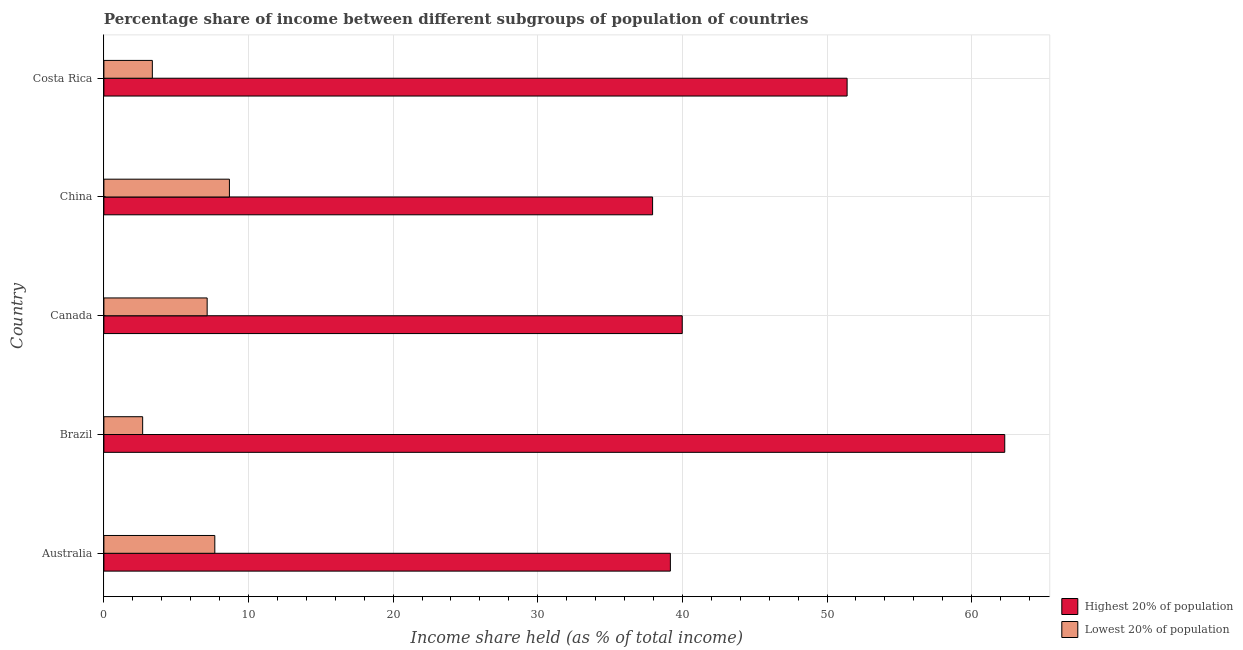How many different coloured bars are there?
Give a very brief answer. 2. How many groups of bars are there?
Your answer should be compact. 5. Are the number of bars on each tick of the Y-axis equal?
Offer a very short reply. Yes. How many bars are there on the 4th tick from the bottom?
Offer a terse response. 2. What is the label of the 2nd group of bars from the top?
Keep it short and to the point. China. What is the income share held by highest 20% of the population in Costa Rica?
Your response must be concise. 51.39. Across all countries, what is the maximum income share held by lowest 20% of the population?
Keep it short and to the point. 8.68. Across all countries, what is the minimum income share held by lowest 20% of the population?
Ensure brevity in your answer.  2.68. In which country was the income share held by highest 20% of the population minimum?
Offer a terse response. China. What is the total income share held by highest 20% of the population in the graph?
Ensure brevity in your answer.  230.78. What is the difference between the income share held by highest 20% of the population in Canada and that in China?
Your answer should be very brief. 2.05. What is the difference between the income share held by lowest 20% of the population in Australia and the income share held by highest 20% of the population in Brazil?
Make the answer very short. -54.62. What is the average income share held by lowest 20% of the population per country?
Provide a succinct answer. 5.9. What is the difference between the income share held by highest 20% of the population and income share held by lowest 20% of the population in Costa Rica?
Your response must be concise. 48.04. What is the ratio of the income share held by highest 20% of the population in Canada to that in China?
Give a very brief answer. 1.05. Is the income share held by lowest 20% of the population in Australia less than that in Costa Rica?
Offer a very short reply. No. Is the difference between the income share held by highest 20% of the population in Canada and China greater than the difference between the income share held by lowest 20% of the population in Canada and China?
Provide a short and direct response. Yes. In how many countries, is the income share held by highest 20% of the population greater than the average income share held by highest 20% of the population taken over all countries?
Make the answer very short. 2. What does the 1st bar from the top in China represents?
Provide a short and direct response. Lowest 20% of population. What does the 1st bar from the bottom in Brazil represents?
Give a very brief answer. Highest 20% of population. How many countries are there in the graph?
Provide a short and direct response. 5. What is the difference between two consecutive major ticks on the X-axis?
Keep it short and to the point. 10. Are the values on the major ticks of X-axis written in scientific E-notation?
Make the answer very short. No. Does the graph contain any zero values?
Ensure brevity in your answer.  No. Where does the legend appear in the graph?
Your answer should be very brief. Bottom right. How many legend labels are there?
Ensure brevity in your answer.  2. What is the title of the graph?
Offer a very short reply. Percentage share of income between different subgroups of population of countries. What is the label or title of the X-axis?
Offer a terse response. Income share held (as % of total income). What is the Income share held (as % of total income) of Highest 20% of population in Australia?
Ensure brevity in your answer.  39.17. What is the Income share held (as % of total income) of Lowest 20% of population in Australia?
Your answer should be very brief. 7.67. What is the Income share held (as % of total income) of Highest 20% of population in Brazil?
Keep it short and to the point. 62.29. What is the Income share held (as % of total income) in Lowest 20% of population in Brazil?
Keep it short and to the point. 2.68. What is the Income share held (as % of total income) of Highest 20% of population in Canada?
Offer a very short reply. 39.99. What is the Income share held (as % of total income) of Lowest 20% of population in Canada?
Provide a succinct answer. 7.14. What is the Income share held (as % of total income) in Highest 20% of population in China?
Your answer should be very brief. 37.94. What is the Income share held (as % of total income) in Lowest 20% of population in China?
Give a very brief answer. 8.68. What is the Income share held (as % of total income) in Highest 20% of population in Costa Rica?
Your response must be concise. 51.39. What is the Income share held (as % of total income) of Lowest 20% of population in Costa Rica?
Ensure brevity in your answer.  3.35. Across all countries, what is the maximum Income share held (as % of total income) of Highest 20% of population?
Your response must be concise. 62.29. Across all countries, what is the maximum Income share held (as % of total income) in Lowest 20% of population?
Your answer should be compact. 8.68. Across all countries, what is the minimum Income share held (as % of total income) of Highest 20% of population?
Provide a succinct answer. 37.94. Across all countries, what is the minimum Income share held (as % of total income) in Lowest 20% of population?
Your answer should be compact. 2.68. What is the total Income share held (as % of total income) of Highest 20% of population in the graph?
Your answer should be very brief. 230.78. What is the total Income share held (as % of total income) in Lowest 20% of population in the graph?
Provide a succinct answer. 29.52. What is the difference between the Income share held (as % of total income) in Highest 20% of population in Australia and that in Brazil?
Your response must be concise. -23.12. What is the difference between the Income share held (as % of total income) in Lowest 20% of population in Australia and that in Brazil?
Your answer should be very brief. 4.99. What is the difference between the Income share held (as % of total income) in Highest 20% of population in Australia and that in Canada?
Provide a succinct answer. -0.82. What is the difference between the Income share held (as % of total income) of Lowest 20% of population in Australia and that in Canada?
Offer a terse response. 0.53. What is the difference between the Income share held (as % of total income) of Highest 20% of population in Australia and that in China?
Provide a succinct answer. 1.23. What is the difference between the Income share held (as % of total income) of Lowest 20% of population in Australia and that in China?
Your response must be concise. -1.01. What is the difference between the Income share held (as % of total income) of Highest 20% of population in Australia and that in Costa Rica?
Provide a succinct answer. -12.22. What is the difference between the Income share held (as % of total income) of Lowest 20% of population in Australia and that in Costa Rica?
Provide a succinct answer. 4.32. What is the difference between the Income share held (as % of total income) in Highest 20% of population in Brazil and that in Canada?
Give a very brief answer. 22.3. What is the difference between the Income share held (as % of total income) of Lowest 20% of population in Brazil and that in Canada?
Provide a succinct answer. -4.46. What is the difference between the Income share held (as % of total income) in Highest 20% of population in Brazil and that in China?
Provide a succinct answer. 24.35. What is the difference between the Income share held (as % of total income) in Lowest 20% of population in Brazil and that in China?
Provide a succinct answer. -6. What is the difference between the Income share held (as % of total income) of Lowest 20% of population in Brazil and that in Costa Rica?
Offer a very short reply. -0.67. What is the difference between the Income share held (as % of total income) of Highest 20% of population in Canada and that in China?
Provide a succinct answer. 2.05. What is the difference between the Income share held (as % of total income) of Lowest 20% of population in Canada and that in China?
Keep it short and to the point. -1.54. What is the difference between the Income share held (as % of total income) in Lowest 20% of population in Canada and that in Costa Rica?
Give a very brief answer. 3.79. What is the difference between the Income share held (as % of total income) of Highest 20% of population in China and that in Costa Rica?
Offer a very short reply. -13.45. What is the difference between the Income share held (as % of total income) of Lowest 20% of population in China and that in Costa Rica?
Ensure brevity in your answer.  5.33. What is the difference between the Income share held (as % of total income) of Highest 20% of population in Australia and the Income share held (as % of total income) of Lowest 20% of population in Brazil?
Give a very brief answer. 36.49. What is the difference between the Income share held (as % of total income) in Highest 20% of population in Australia and the Income share held (as % of total income) in Lowest 20% of population in Canada?
Your answer should be compact. 32.03. What is the difference between the Income share held (as % of total income) in Highest 20% of population in Australia and the Income share held (as % of total income) in Lowest 20% of population in China?
Ensure brevity in your answer.  30.49. What is the difference between the Income share held (as % of total income) in Highest 20% of population in Australia and the Income share held (as % of total income) in Lowest 20% of population in Costa Rica?
Your answer should be very brief. 35.82. What is the difference between the Income share held (as % of total income) in Highest 20% of population in Brazil and the Income share held (as % of total income) in Lowest 20% of population in Canada?
Offer a terse response. 55.15. What is the difference between the Income share held (as % of total income) in Highest 20% of population in Brazil and the Income share held (as % of total income) in Lowest 20% of population in China?
Your answer should be compact. 53.61. What is the difference between the Income share held (as % of total income) of Highest 20% of population in Brazil and the Income share held (as % of total income) of Lowest 20% of population in Costa Rica?
Provide a short and direct response. 58.94. What is the difference between the Income share held (as % of total income) of Highest 20% of population in Canada and the Income share held (as % of total income) of Lowest 20% of population in China?
Offer a terse response. 31.31. What is the difference between the Income share held (as % of total income) of Highest 20% of population in Canada and the Income share held (as % of total income) of Lowest 20% of population in Costa Rica?
Your answer should be very brief. 36.64. What is the difference between the Income share held (as % of total income) in Highest 20% of population in China and the Income share held (as % of total income) in Lowest 20% of population in Costa Rica?
Offer a very short reply. 34.59. What is the average Income share held (as % of total income) of Highest 20% of population per country?
Your answer should be compact. 46.16. What is the average Income share held (as % of total income) of Lowest 20% of population per country?
Offer a terse response. 5.9. What is the difference between the Income share held (as % of total income) in Highest 20% of population and Income share held (as % of total income) in Lowest 20% of population in Australia?
Keep it short and to the point. 31.5. What is the difference between the Income share held (as % of total income) in Highest 20% of population and Income share held (as % of total income) in Lowest 20% of population in Brazil?
Provide a short and direct response. 59.61. What is the difference between the Income share held (as % of total income) in Highest 20% of population and Income share held (as % of total income) in Lowest 20% of population in Canada?
Offer a very short reply. 32.85. What is the difference between the Income share held (as % of total income) in Highest 20% of population and Income share held (as % of total income) in Lowest 20% of population in China?
Keep it short and to the point. 29.26. What is the difference between the Income share held (as % of total income) in Highest 20% of population and Income share held (as % of total income) in Lowest 20% of population in Costa Rica?
Your response must be concise. 48.04. What is the ratio of the Income share held (as % of total income) in Highest 20% of population in Australia to that in Brazil?
Offer a very short reply. 0.63. What is the ratio of the Income share held (as % of total income) of Lowest 20% of population in Australia to that in Brazil?
Keep it short and to the point. 2.86. What is the ratio of the Income share held (as % of total income) of Highest 20% of population in Australia to that in Canada?
Make the answer very short. 0.98. What is the ratio of the Income share held (as % of total income) of Lowest 20% of population in Australia to that in Canada?
Make the answer very short. 1.07. What is the ratio of the Income share held (as % of total income) in Highest 20% of population in Australia to that in China?
Make the answer very short. 1.03. What is the ratio of the Income share held (as % of total income) of Lowest 20% of population in Australia to that in China?
Your answer should be very brief. 0.88. What is the ratio of the Income share held (as % of total income) of Highest 20% of population in Australia to that in Costa Rica?
Ensure brevity in your answer.  0.76. What is the ratio of the Income share held (as % of total income) in Lowest 20% of population in Australia to that in Costa Rica?
Make the answer very short. 2.29. What is the ratio of the Income share held (as % of total income) of Highest 20% of population in Brazil to that in Canada?
Ensure brevity in your answer.  1.56. What is the ratio of the Income share held (as % of total income) in Lowest 20% of population in Brazil to that in Canada?
Your response must be concise. 0.38. What is the ratio of the Income share held (as % of total income) in Highest 20% of population in Brazil to that in China?
Give a very brief answer. 1.64. What is the ratio of the Income share held (as % of total income) of Lowest 20% of population in Brazil to that in China?
Make the answer very short. 0.31. What is the ratio of the Income share held (as % of total income) in Highest 20% of population in Brazil to that in Costa Rica?
Offer a terse response. 1.21. What is the ratio of the Income share held (as % of total income) of Lowest 20% of population in Brazil to that in Costa Rica?
Keep it short and to the point. 0.8. What is the ratio of the Income share held (as % of total income) of Highest 20% of population in Canada to that in China?
Provide a succinct answer. 1.05. What is the ratio of the Income share held (as % of total income) in Lowest 20% of population in Canada to that in China?
Provide a succinct answer. 0.82. What is the ratio of the Income share held (as % of total income) of Highest 20% of population in Canada to that in Costa Rica?
Ensure brevity in your answer.  0.78. What is the ratio of the Income share held (as % of total income) in Lowest 20% of population in Canada to that in Costa Rica?
Make the answer very short. 2.13. What is the ratio of the Income share held (as % of total income) in Highest 20% of population in China to that in Costa Rica?
Your answer should be very brief. 0.74. What is the ratio of the Income share held (as % of total income) in Lowest 20% of population in China to that in Costa Rica?
Keep it short and to the point. 2.59. What is the difference between the highest and the second highest Income share held (as % of total income) in Lowest 20% of population?
Offer a terse response. 1.01. What is the difference between the highest and the lowest Income share held (as % of total income) of Highest 20% of population?
Offer a terse response. 24.35. What is the difference between the highest and the lowest Income share held (as % of total income) of Lowest 20% of population?
Offer a very short reply. 6. 